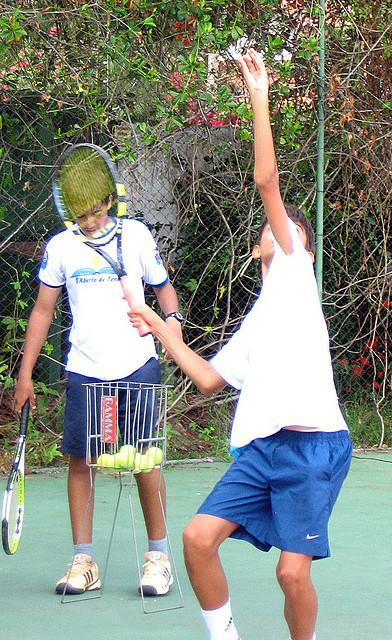What color are the interior nettings of the rackets used by the two men?

Choices:
A) white
B) blue
C) red
D) green green 